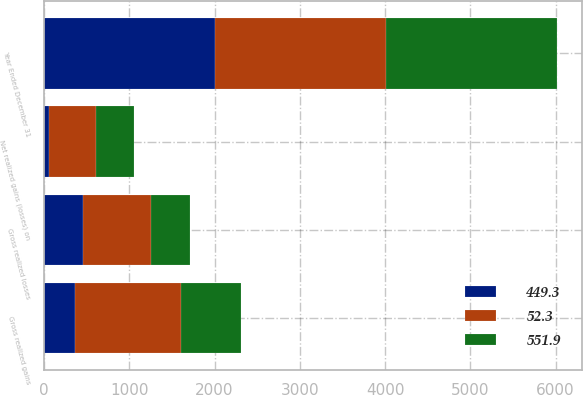Convert chart. <chart><loc_0><loc_0><loc_500><loc_500><stacked_bar_chart><ecel><fcel>Year Ended December 31<fcel>Gross realized gains<fcel>Gross realized losses<fcel>Net realized gains (losses) on<nl><fcel>449.3<fcel>2005<fcel>360.7<fcel>451.2<fcel>52.3<nl><fcel>551.9<fcel>2004<fcel>703.9<fcel>456.8<fcel>449.3<nl><fcel>52.3<fcel>2003<fcel>1244<fcel>806.6<fcel>551.9<nl></chart> 